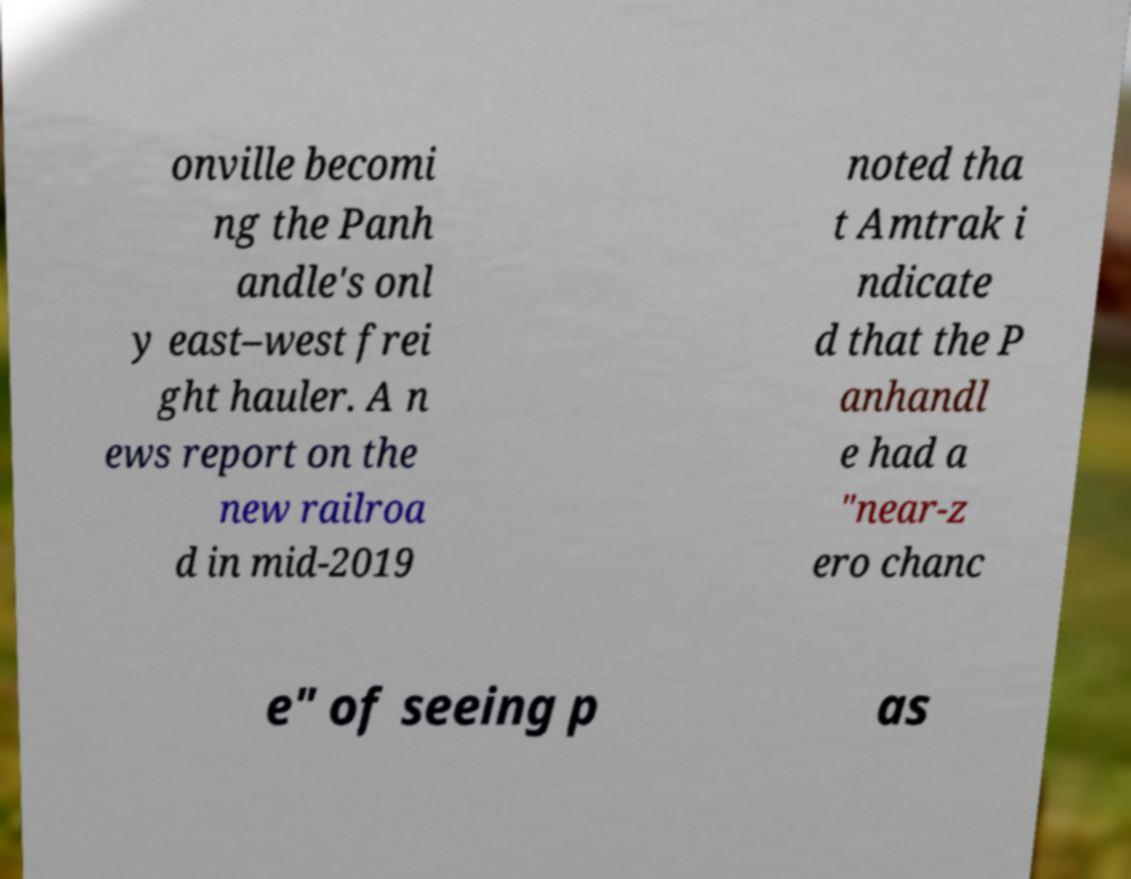Could you extract and type out the text from this image? onville becomi ng the Panh andle's onl y east–west frei ght hauler. A n ews report on the new railroa d in mid-2019 noted tha t Amtrak i ndicate d that the P anhandl e had a "near-z ero chanc e" of seeing p as 